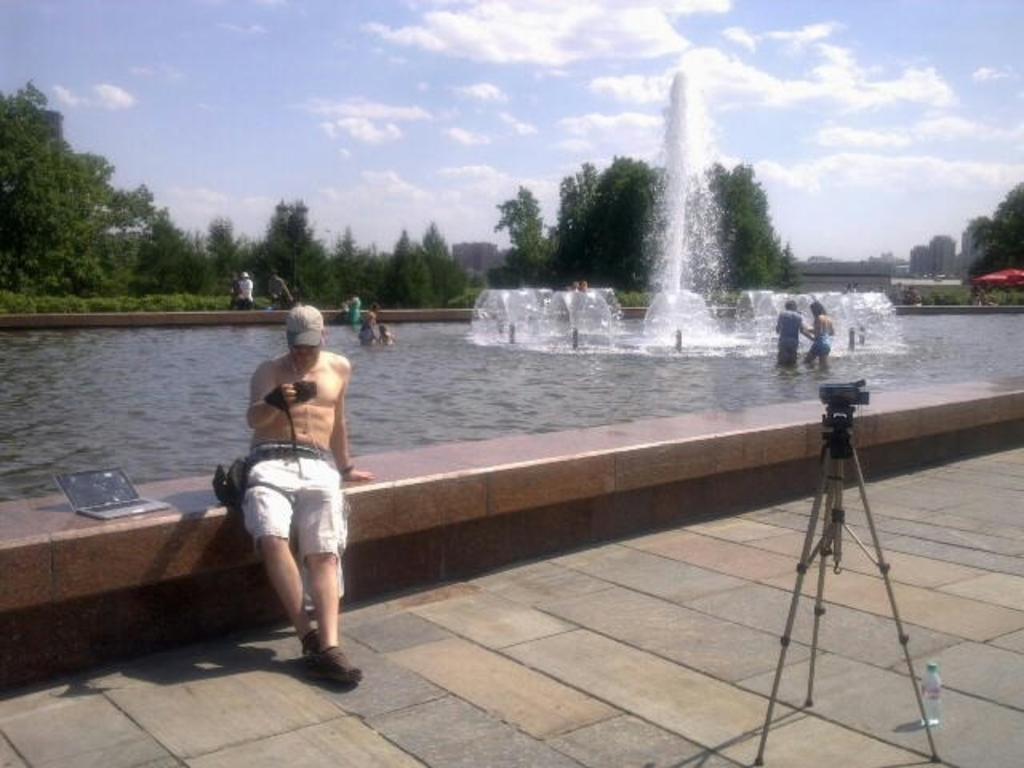Could you give a brief overview of what you see in this image? There is one camera and a bottle at the bottom right corner of this image. There is one person sitting on a boundary wall and holding a camera on the left side of this image, and there is a laptop on the left side to him. There is a fountain in the background. There are some persons as we can see in the middle of this image, and there are some trees in the background. There is a cloudy sky at the top of this image. 